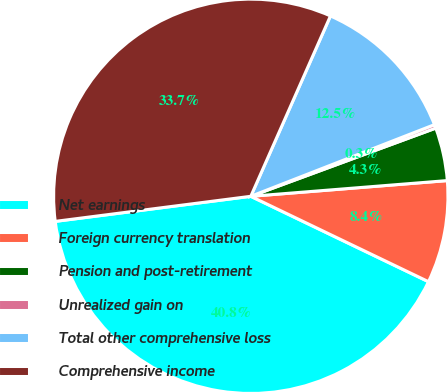Convert chart to OTSL. <chart><loc_0><loc_0><loc_500><loc_500><pie_chart><fcel>Net earnings<fcel>Foreign currency translation<fcel>Pension and post-retirement<fcel>Unrealized gain on<fcel>Total other comprehensive loss<fcel>Comprehensive income<nl><fcel>40.84%<fcel>8.4%<fcel>4.35%<fcel>0.3%<fcel>12.46%<fcel>33.65%<nl></chart> 